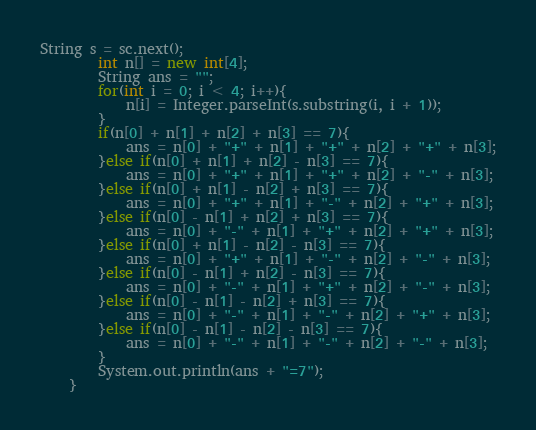<code> <loc_0><loc_0><loc_500><loc_500><_Java_>String s = sc.next();
        int n[] = new int[4];
        String ans = "";
        for(int i = 0; i < 4; i++){
        	n[i] = Integer.parseInt(s.substring(i, i + 1));
        }
        if(n[0] + n[1] + n[2] + n[3] == 7){
        	ans = n[0] + "+" + n[1] + "+" + n[2] + "+" + n[3];
        }else if(n[0] + n[1] + n[2] - n[3] == 7){
        	ans = n[0] + "+" + n[1] + "+" + n[2] + "-" + n[3];
        }else if(n[0] + n[1] - n[2] + n[3] == 7){
        	ans = n[0] + "+" + n[1] + "-" + n[2] + "+" + n[3];
        }else if(n[0] - n[1] + n[2] + n[3] == 7){
        	ans = n[0] + "-" + n[1] + "+" + n[2] + "+" + n[3];
        }else if(n[0] + n[1] - n[2] - n[3] == 7){
        	ans = n[0] + "+" + n[1] + "-" + n[2] + "-" + n[3];
        }else if(n[0] - n[1] + n[2] - n[3] == 7){
        	ans = n[0] + "-" + n[1] + "+" + n[2] + "-" + n[3];
        }else if(n[0] - n[1] - n[2] + n[3] == 7){
        	ans = n[0] + "-" + n[1] + "-" + n[2] + "+" + n[3];
        }else if(n[0] - n[1] - n[2] - n[3] == 7){
        	ans = n[0] + "-" + n[1] + "-" + n[2] + "-" + n[3];
        }
        System.out.println(ans + "=7");
    }</code> 